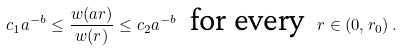<formula> <loc_0><loc_0><loc_500><loc_500>c _ { 1 } a ^ { - b } \leq \frac { w ( a r ) } { w ( r ) } \leq c _ { 2 } a ^ { - b } \ \text { for every } \ r \in ( 0 , r _ { 0 } ) \, .</formula> 